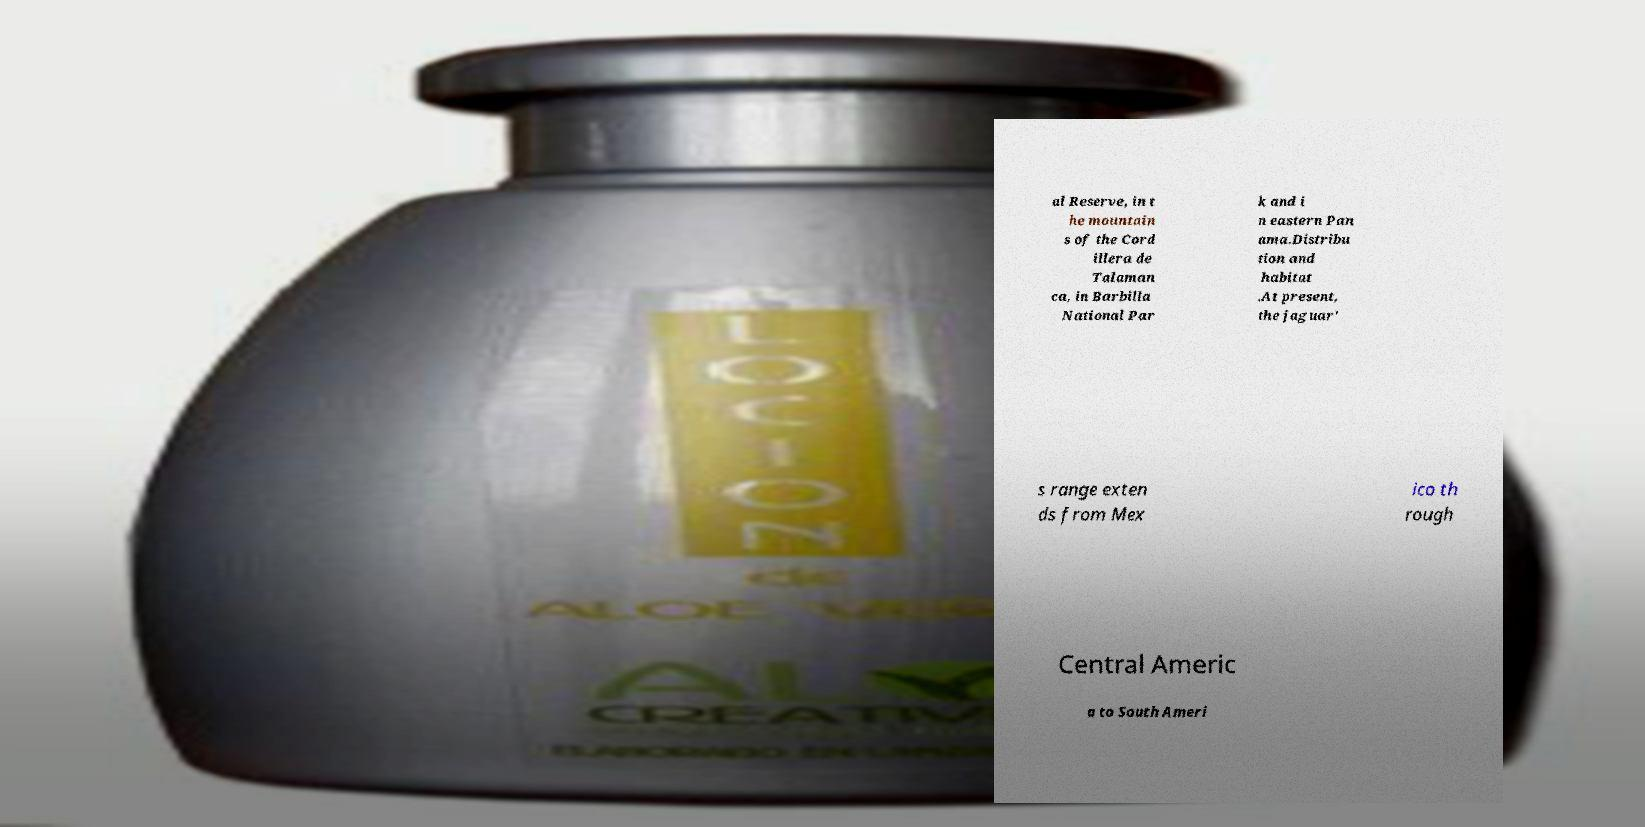For documentation purposes, I need the text within this image transcribed. Could you provide that? al Reserve, in t he mountain s of the Cord illera de Talaman ca, in Barbilla National Par k and i n eastern Pan ama.Distribu tion and habitat .At present, the jaguar' s range exten ds from Mex ico th rough Central Americ a to South Ameri 